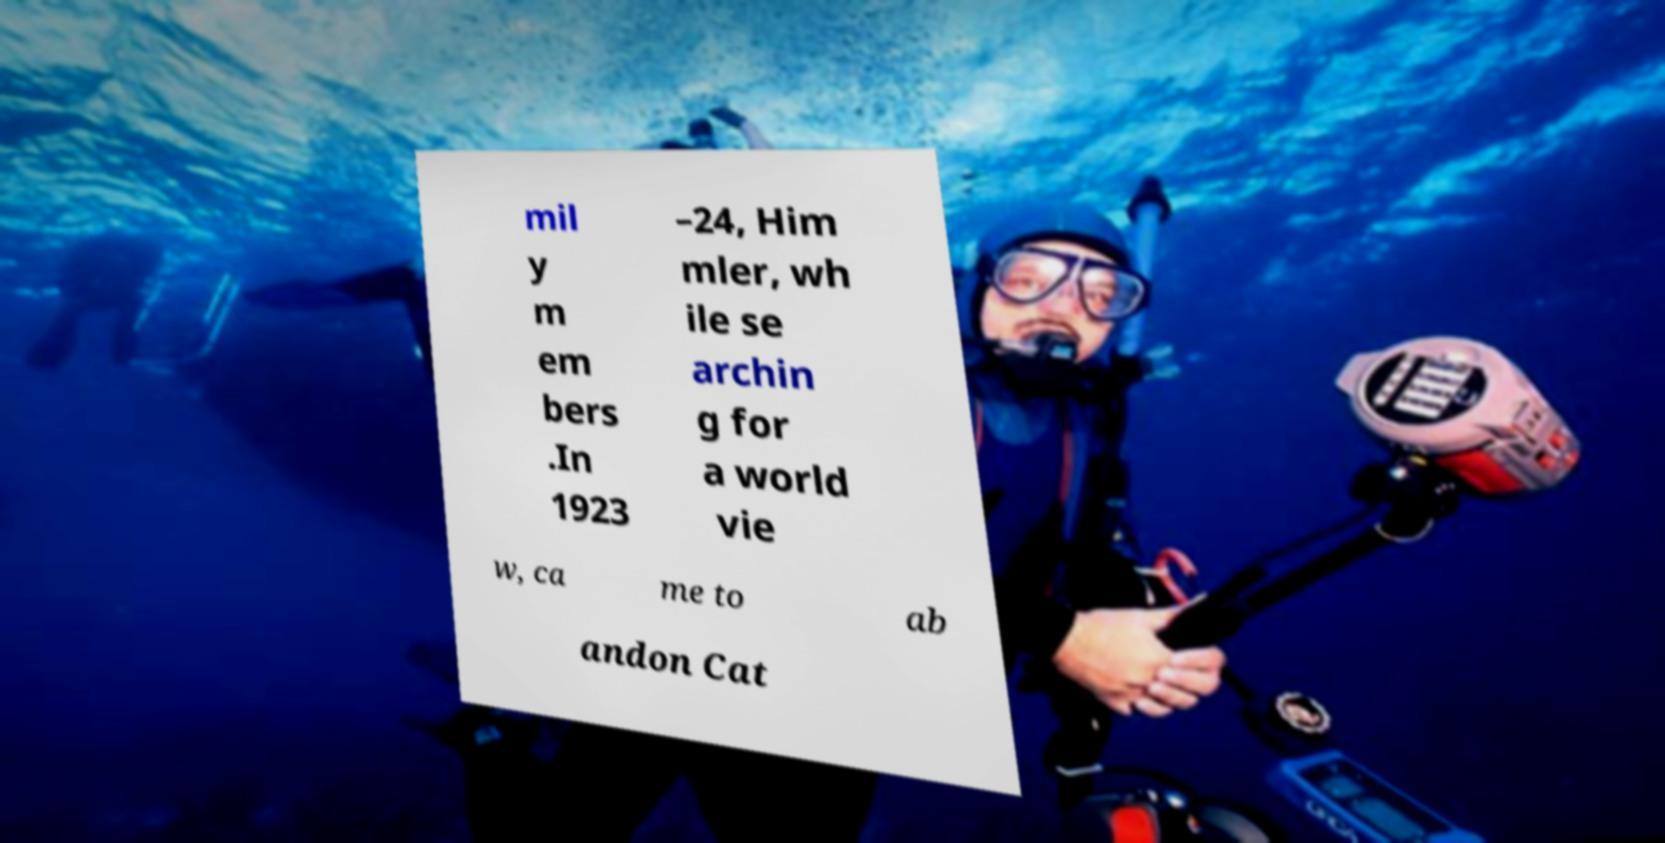I need the written content from this picture converted into text. Can you do that? mil y m em bers .In 1923 –24, Him mler, wh ile se archin g for a world vie w, ca me to ab andon Cat 